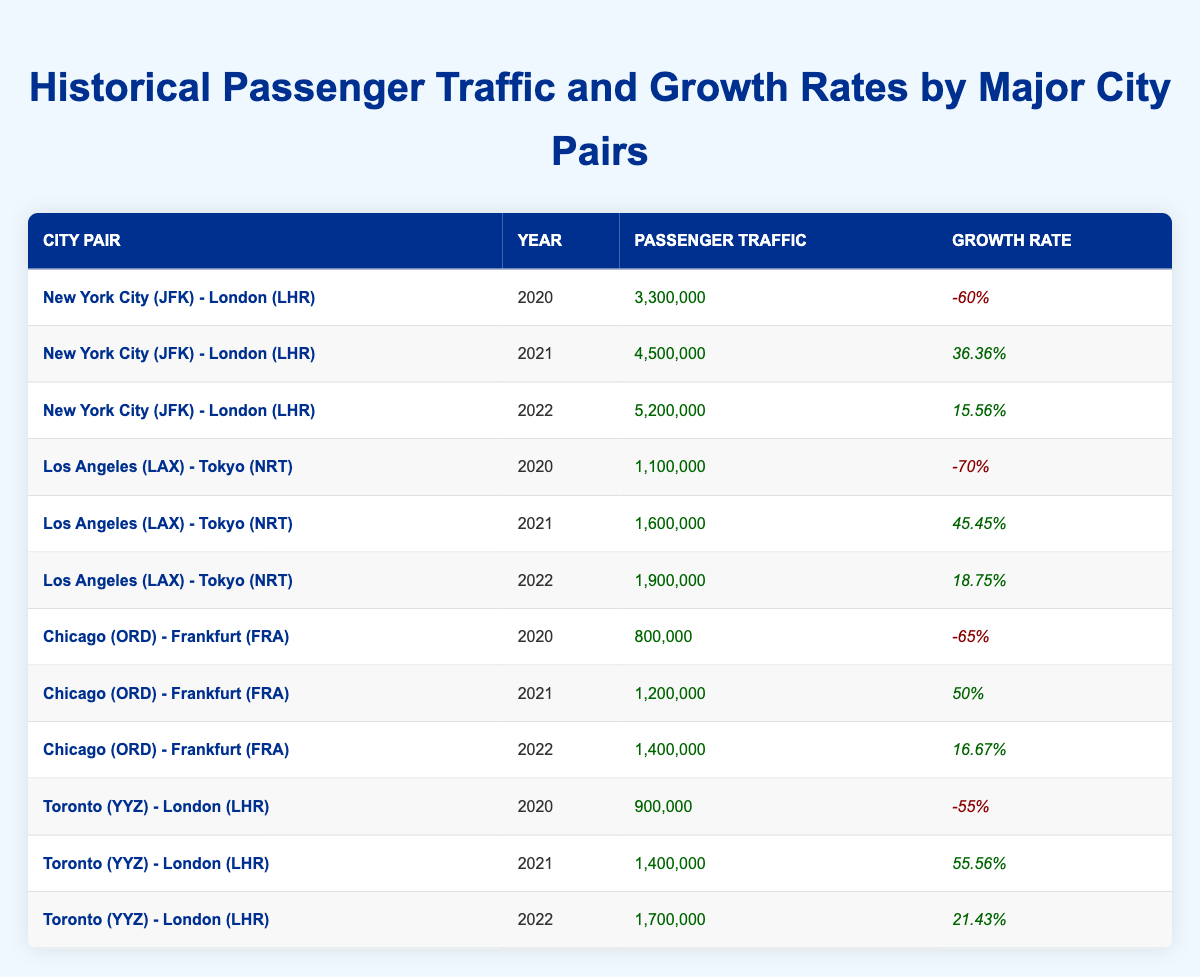What was the passenger traffic from New York City to London in 2021? The table shows that for the city pair New York City (JFK) - London (LHR), the passenger traffic in 2021 was listed as 4,500,000.
Answer: 4,500,000 What was the growth rate for the Los Angeles to Tokyo route in 2022? Looking at the Los Angeles (LAX) - Tokyo (NRT) data, the growth rate reported for 2022 is 18.75%.
Answer: 18.75% Which city pair had the highest passenger traffic in 2022? By comparing the passenger traffic values for all routes in 2022, New York City (JFK) - London (LHR) had the highest traffic at 5,200,000.
Answer: New York City (JFK) - London (LHR) What is the average growth rate for the Chicago to Frankfurt route from 2021 to 2022? The growth rates for Chicago (ORD) - Frankfurt (FRA) in 2021 and 2022 are 50% and 16.67%, respectively. To find the average, sum both growth rates (50 + 16.67 = 66.67) and divide by 2, resulting in an average growth rate of 33.335%.
Answer: 33.335% Did Toronto to London see a positive growth rate in both 2021 and 2022? For Toronto (YYZ) - London (LHR), the growth rates in 2021 and 2022 were 55.56% and 21.43%, respectively, both of which are positive. Therefore, the statement is true.
Answer: Yes What was the total passenger traffic for the New York City to London route across all three years? The passenger traffic for New York City (JFK) - London (LHR) across the years is 3,300,000 in 2020, 4,500,000 in 2021, and 5,200,000 in 2022. The total is found by adding these numbers together: (3,300,000 + 4,500,000 + 5,200,000) = 13,000,000.
Answer: 13,000,000 Is there any city pair with a negative growth rate in 2022? By checking the growth rates for all city pairs in 2022, we can confirm that all growth rates for 2022 are positive. Thus, no city pair has a negative growth rate in that year.
Answer: No Which city pair experienced the most significant increase in passenger traffic from 2020 to 2021? Examining the data, Los Angeles (LAX) - Tokyo (NRT) increased from 1,100,000 in 2020 to 1,600,000 in 2021, which is a change of 500,000. New York City (JFK) - London (LHR) increased from 3,300,000 to 4,500,000, representing an increase of 1,200,000. Therefore, New York City (JFK) - London (LHR) experienced the most significant increase.
Answer: New York City (JFK) - London (LHR) What was the growth rate for the Toronto to London route in 2020 and how did it compare to 2021? The growth rate for Toronto (YYZ) - London (LHR) in 2020 was -55%, which is negative, while in 2021 it grew to 55.56%, indicating a significant positive turnaround.
Answer: -55% then 55.56% 